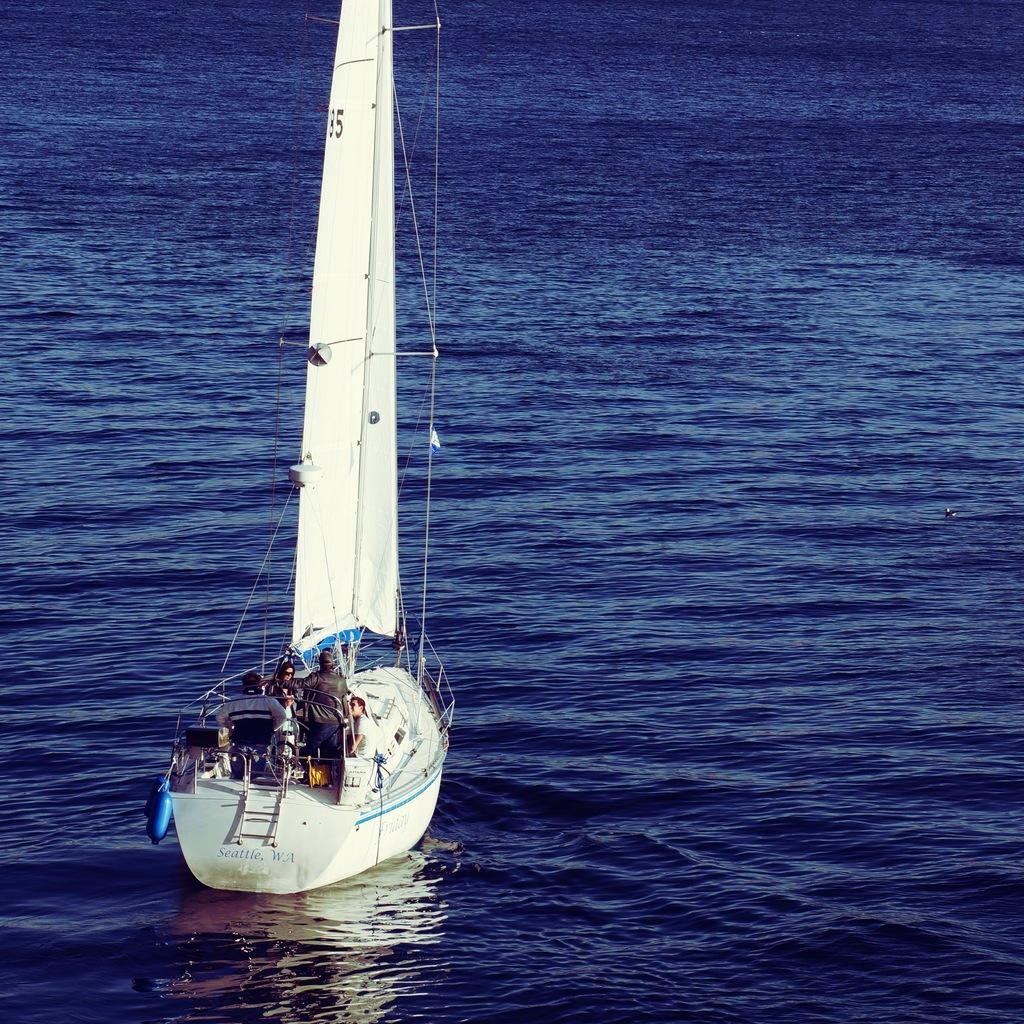What is the main subject of the image? The main subject of the image is a boat. What can be seen in the background of the image? There is water in the image. Who or what is inside the boat? There are people in the boat. Are there any objects present in the boat? Yes, there are objects in the boat. What date is marked on the calendar in the boat? There is no calendar present in the image. How many giants can be seen in the boat? There are no giants present in the image. 